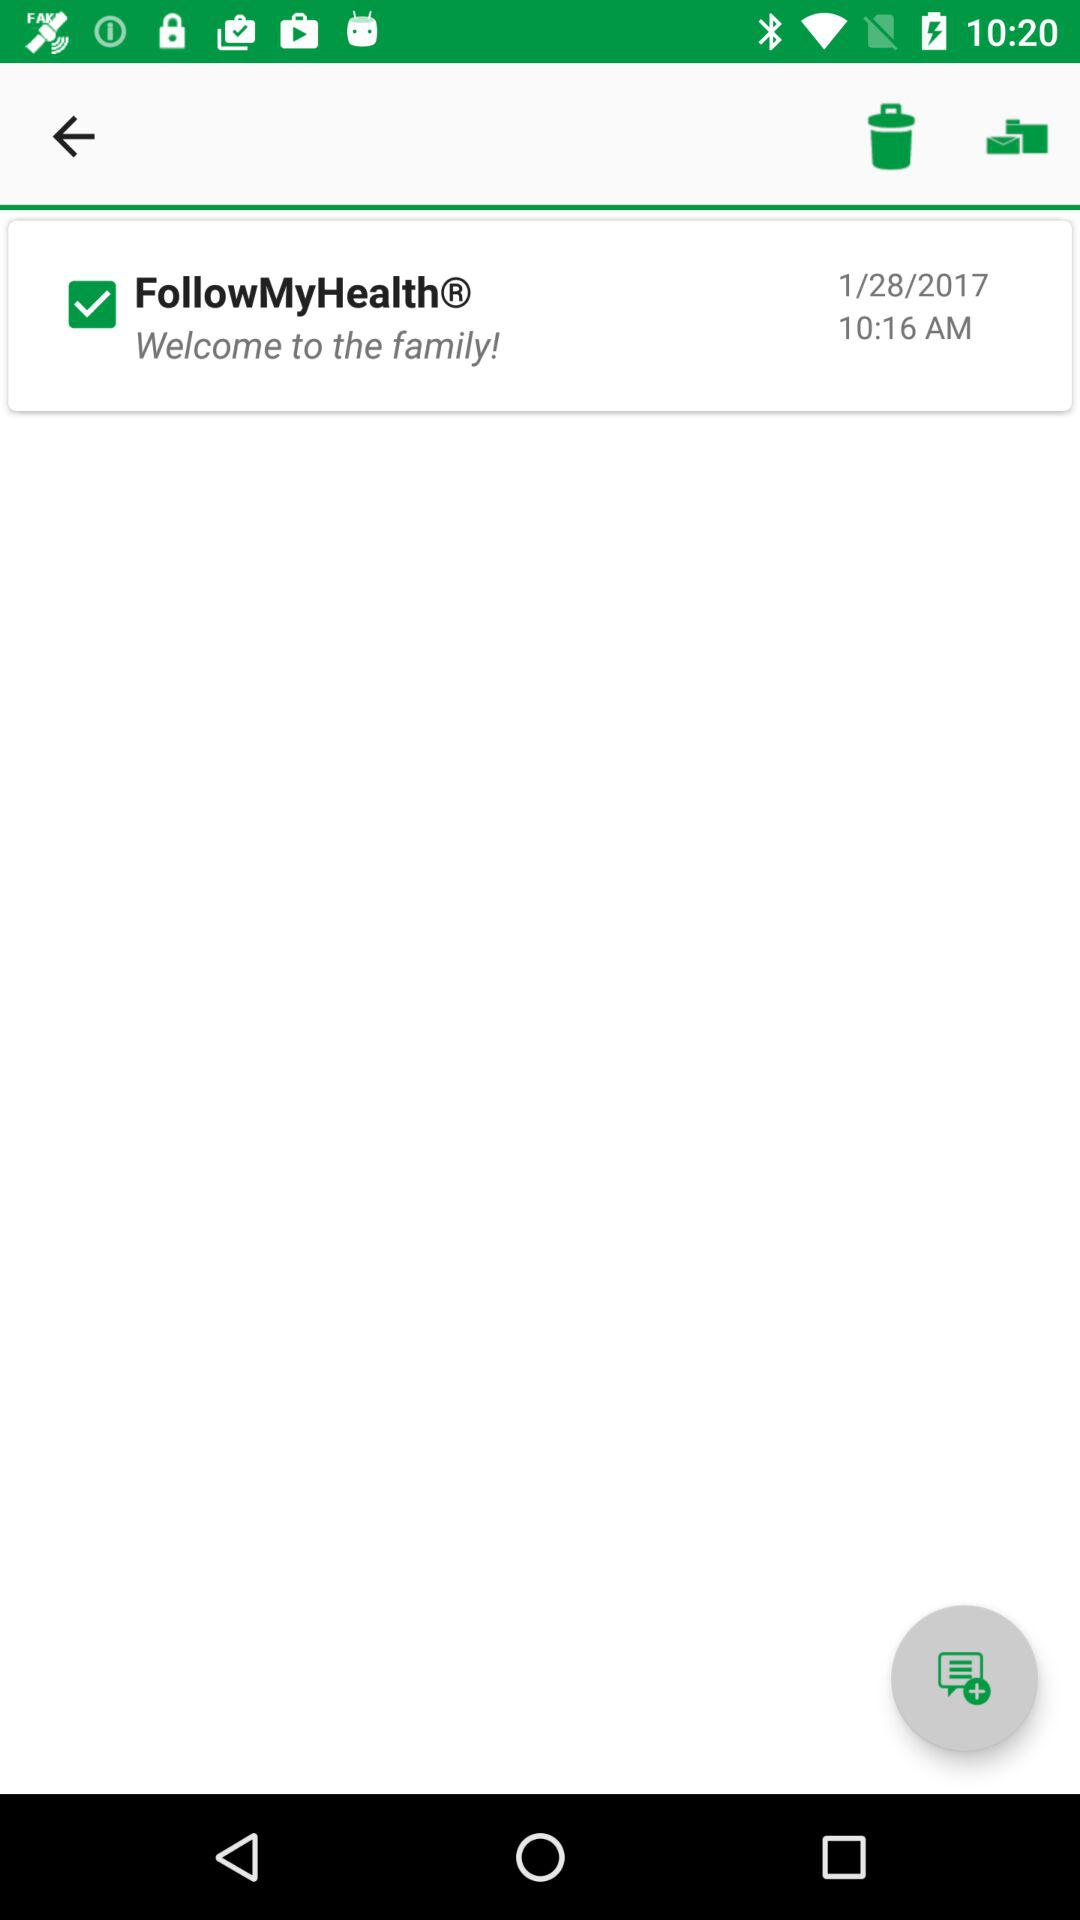What is the status of the "FollowMyHealthⓇ"? The status is "on". 